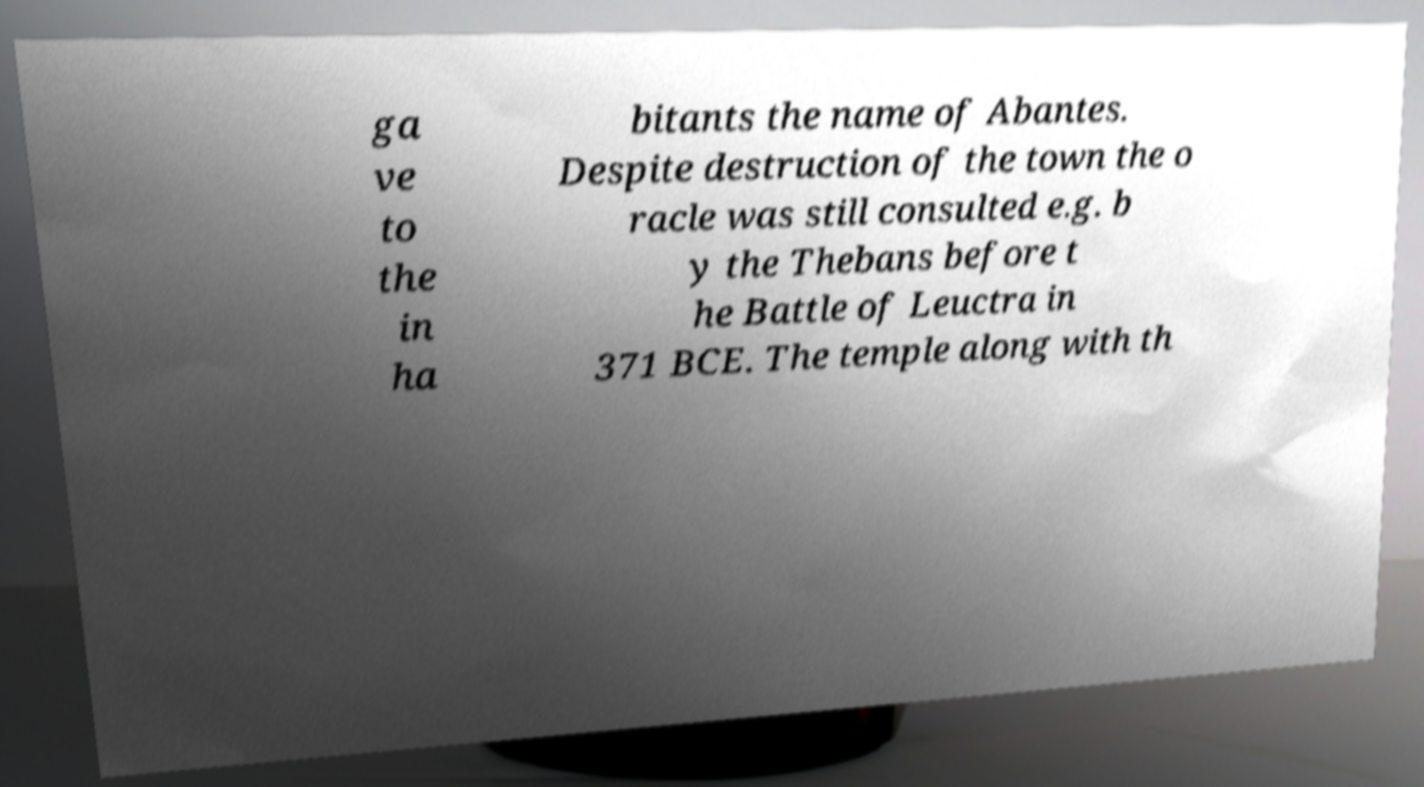Could you assist in decoding the text presented in this image and type it out clearly? ga ve to the in ha bitants the name of Abantes. Despite destruction of the town the o racle was still consulted e.g. b y the Thebans before t he Battle of Leuctra in 371 BCE. The temple along with th 